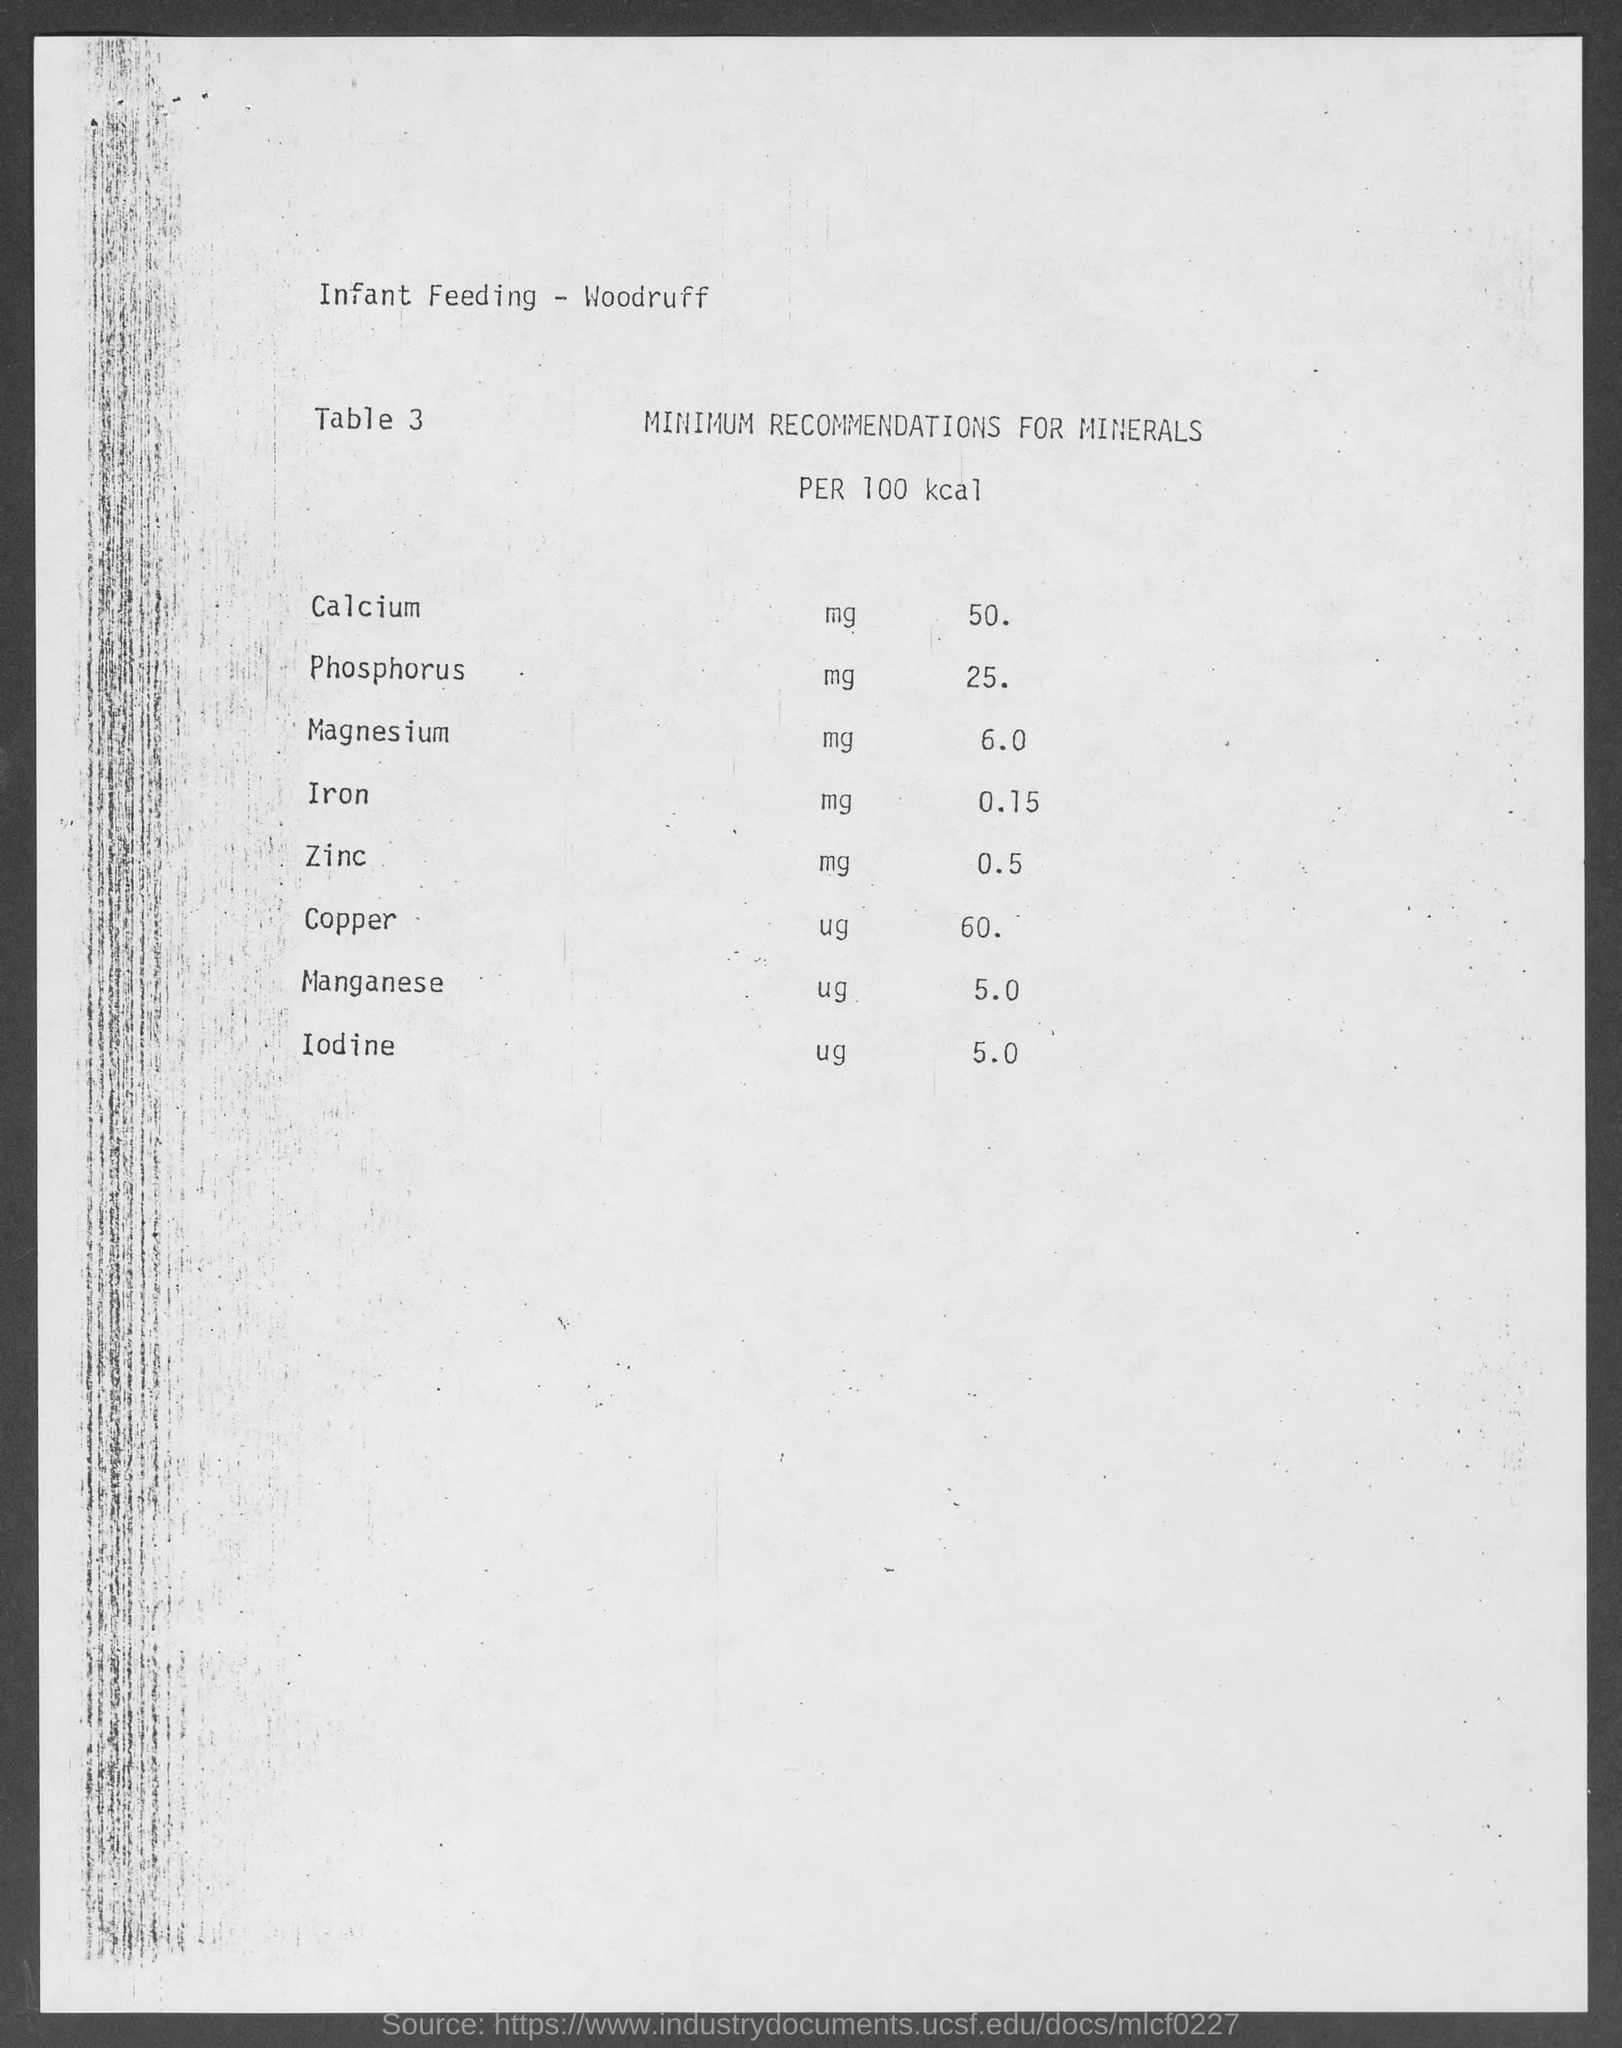What is the minimum recommendation of calcium per 100 kcal?
Offer a terse response. 50. What is the minimum recommendation of phosphorous per 100 kcal?
Your answer should be compact. 25. What is the minimum recommendation of magnesium per 100 kcal?
Your answer should be very brief. 6.0. What is the minimum recommendation of iron per 100 kcal?
Make the answer very short. 0.15. What is the minimum recommendation of zinc per 100 kcal?
Offer a terse response. 0.5. What is the minimum recommendation of copper per 100 kcal?
Give a very brief answer. 60. What is the minimum recommendation of manganese per 100 kcal?
Give a very brief answer. 5.0. What is the minimum recommendation of iodine per 100 kcal?
Give a very brief answer. 5.0. What is the title of table 3?
Offer a very short reply. MINIMUM RECOMMENDATIONS FOR MINERALS PER 100 kcal. 